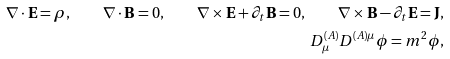Convert formula to latex. <formula><loc_0><loc_0><loc_500><loc_500>\nabla \cdot \mathbf E = \rho , \quad \nabla \cdot \mathbf B = 0 , \quad \nabla \times \mathbf E + \partial _ { t } \mathbf B = 0 , \quad \nabla \times \mathbf B - \partial _ { t } \mathbf E = \mathbf J , \\ D ^ { ( A ) } _ { \mu } D ^ { ( A ) \mu } \phi = m ^ { 2 } \phi ,</formula> 